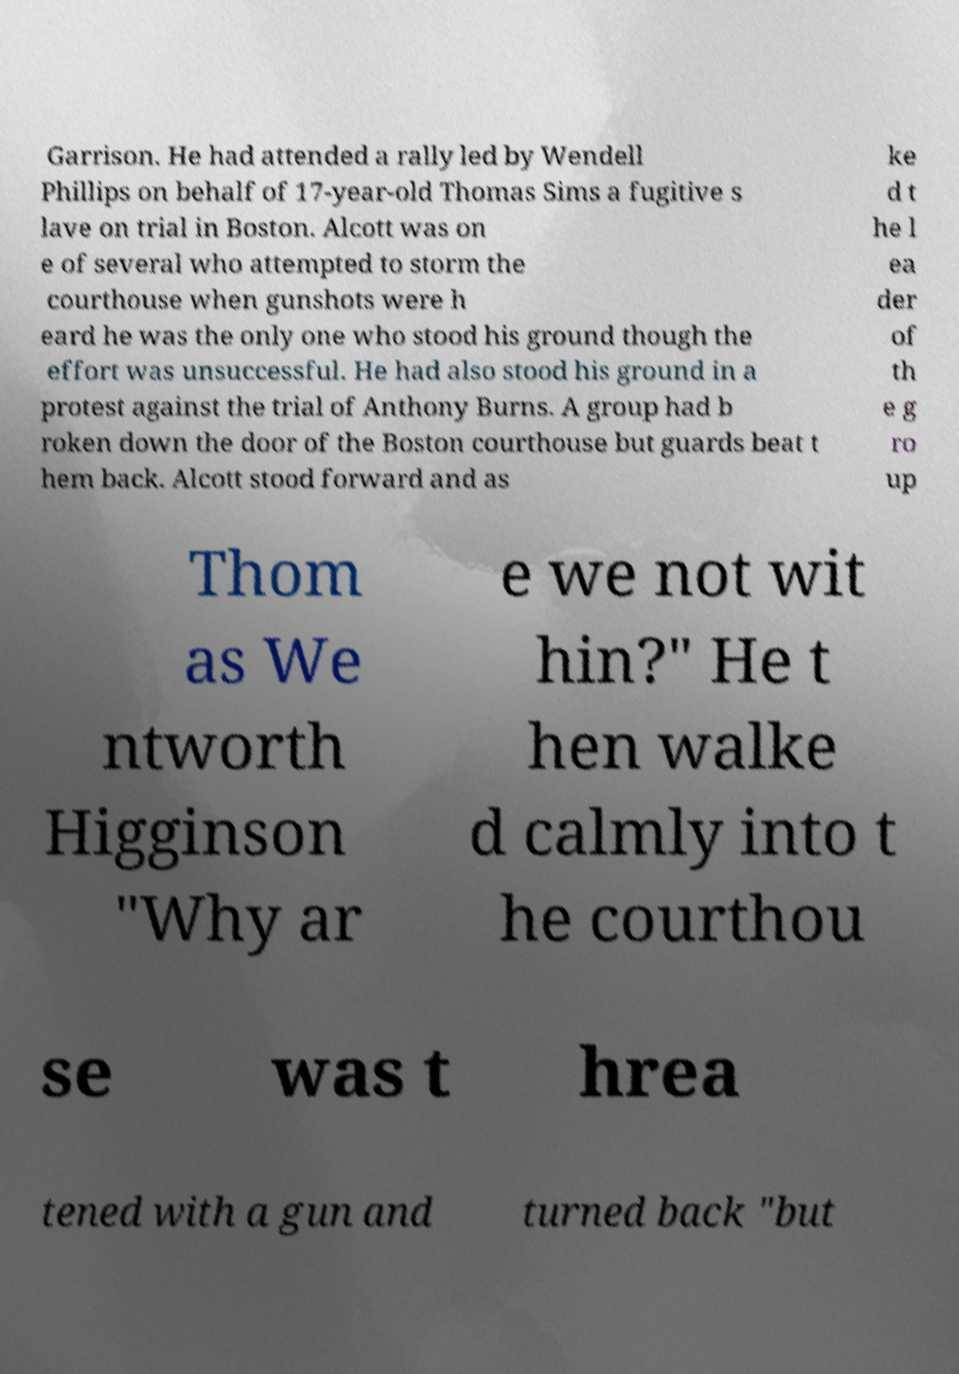For documentation purposes, I need the text within this image transcribed. Could you provide that? Garrison. He had attended a rally led by Wendell Phillips on behalf of 17-year-old Thomas Sims a fugitive s lave on trial in Boston. Alcott was on e of several who attempted to storm the courthouse when gunshots were h eard he was the only one who stood his ground though the effort was unsuccessful. He had also stood his ground in a protest against the trial of Anthony Burns. A group had b roken down the door of the Boston courthouse but guards beat t hem back. Alcott stood forward and as ke d t he l ea der of th e g ro up Thom as We ntworth Higginson "Why ar e we not wit hin?" He t hen walke d calmly into t he courthou se was t hrea tened with a gun and turned back "but 